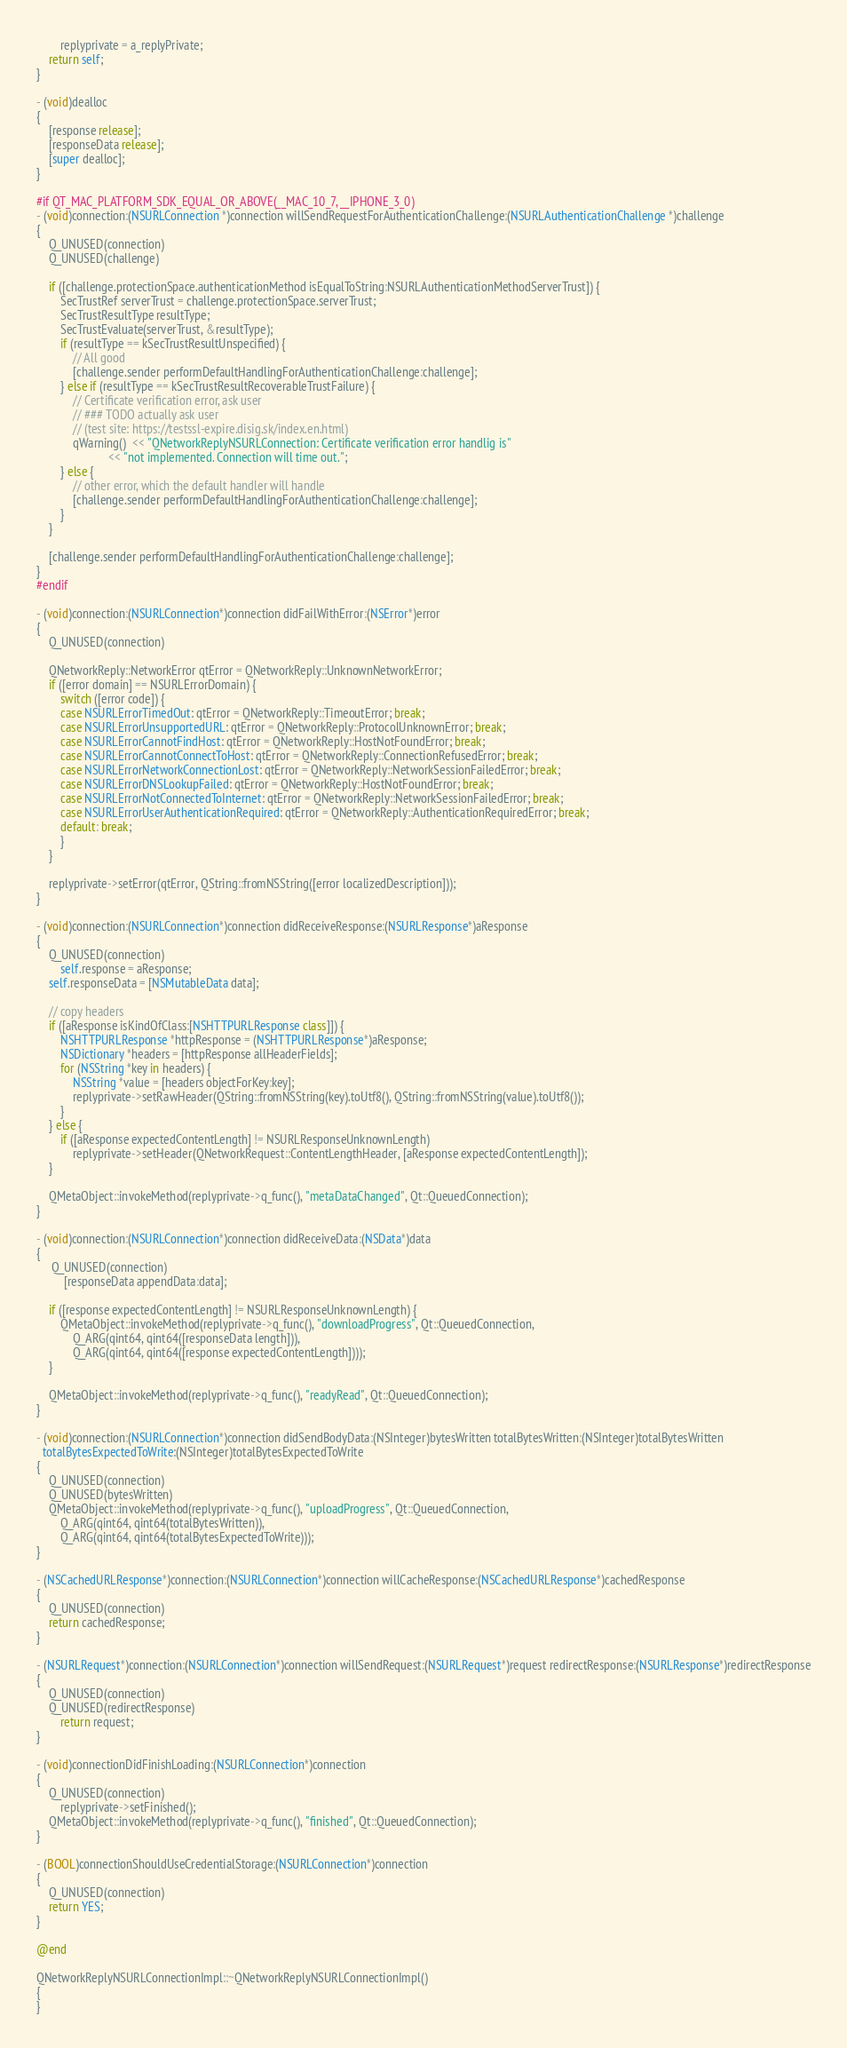<code> <loc_0><loc_0><loc_500><loc_500><_ObjectiveC_>        replyprivate = a_replyPrivate;
    return self;
}

- (void)dealloc
{
    [response release];
    [responseData release];
    [super dealloc];
}

#if QT_MAC_PLATFORM_SDK_EQUAL_OR_ABOVE(__MAC_10_7, __IPHONE_3_0)
- (void)connection:(NSURLConnection *)connection willSendRequestForAuthenticationChallenge:(NSURLAuthenticationChallenge *)challenge
{
    Q_UNUSED(connection)
    Q_UNUSED(challenge)

    if ([challenge.protectionSpace.authenticationMethod isEqualToString:NSURLAuthenticationMethodServerTrust]) {
        SecTrustRef serverTrust = challenge.protectionSpace.serverTrust;
        SecTrustResultType resultType;
        SecTrustEvaluate(serverTrust, &resultType);
        if (resultType == kSecTrustResultUnspecified) {
            // All good
            [challenge.sender performDefaultHandlingForAuthenticationChallenge:challenge];
        } else if (resultType == kSecTrustResultRecoverableTrustFailure) {
            // Certificate verification error, ask user
            // ### TODO actually ask user
            // (test site: https://testssl-expire.disig.sk/index.en.html)
            qWarning()  << "QNetworkReplyNSURLConnection: Certificate verification error handlig is"
                        << "not implemented. Connection will time out.";
        } else {
            // other error, which the default handler will handle
            [challenge.sender performDefaultHandlingForAuthenticationChallenge:challenge];
        }
    }

    [challenge.sender performDefaultHandlingForAuthenticationChallenge:challenge];
}
#endif

- (void)connection:(NSURLConnection*)connection didFailWithError:(NSError*)error
{
    Q_UNUSED(connection)

    QNetworkReply::NetworkError qtError = QNetworkReply::UnknownNetworkError;
    if ([error domain] == NSURLErrorDomain) {
        switch ([error code]) {
        case NSURLErrorTimedOut: qtError = QNetworkReply::TimeoutError; break;
        case NSURLErrorUnsupportedURL: qtError = QNetworkReply::ProtocolUnknownError; break;
        case NSURLErrorCannotFindHost: qtError = QNetworkReply::HostNotFoundError; break;
        case NSURLErrorCannotConnectToHost: qtError = QNetworkReply::ConnectionRefusedError; break;
        case NSURLErrorNetworkConnectionLost: qtError = QNetworkReply::NetworkSessionFailedError; break;
        case NSURLErrorDNSLookupFailed: qtError = QNetworkReply::HostNotFoundError; break;
        case NSURLErrorNotConnectedToInternet: qtError = QNetworkReply::NetworkSessionFailedError; break;
        case NSURLErrorUserAuthenticationRequired: qtError = QNetworkReply::AuthenticationRequiredError; break;
        default: break;
        }
    }

    replyprivate->setError(qtError, QString::fromNSString([error localizedDescription]));
}

- (void)connection:(NSURLConnection*)connection didReceiveResponse:(NSURLResponse*)aResponse
{
    Q_UNUSED(connection)
        self.response = aResponse;
    self.responseData = [NSMutableData data];

    // copy headers
    if ([aResponse isKindOfClass:[NSHTTPURLResponse class]]) {
        NSHTTPURLResponse *httpResponse = (NSHTTPURLResponse*)aResponse;
        NSDictionary *headers = [httpResponse allHeaderFields];
        for (NSString *key in headers) {
            NSString *value = [headers objectForKey:key];
            replyprivate->setRawHeader(QString::fromNSString(key).toUtf8(), QString::fromNSString(value).toUtf8());
        }
    } else {
        if ([aResponse expectedContentLength] != NSURLResponseUnknownLength)
            replyprivate->setHeader(QNetworkRequest::ContentLengthHeader, [aResponse expectedContentLength]);
    }

    QMetaObject::invokeMethod(replyprivate->q_func(), "metaDataChanged", Qt::QueuedConnection);
}

- (void)connection:(NSURLConnection*)connection didReceiveData:(NSData*)data
{
     Q_UNUSED(connection)
         [responseData appendData:data];

    if ([response expectedContentLength] != NSURLResponseUnknownLength) {
        QMetaObject::invokeMethod(replyprivate->q_func(), "downloadProgress", Qt::QueuedConnection,
            Q_ARG(qint64, qint64([responseData length])),
            Q_ARG(qint64, qint64([response expectedContentLength])));
    }

    QMetaObject::invokeMethod(replyprivate->q_func(), "readyRead", Qt::QueuedConnection);
}

- (void)connection:(NSURLConnection*)connection didSendBodyData:(NSInteger)bytesWritten totalBytesWritten:(NSInteger)totalBytesWritten
  totalBytesExpectedToWrite:(NSInteger)totalBytesExpectedToWrite
{
    Q_UNUSED(connection)
    Q_UNUSED(bytesWritten)
    QMetaObject::invokeMethod(replyprivate->q_func(), "uploadProgress", Qt::QueuedConnection,
        Q_ARG(qint64, qint64(totalBytesWritten)),
        Q_ARG(qint64, qint64(totalBytesExpectedToWrite)));
}

- (NSCachedURLResponse*)connection:(NSURLConnection*)connection willCacheResponse:(NSCachedURLResponse*)cachedResponse
{
    Q_UNUSED(connection)
    return cachedResponse;
}

- (NSURLRequest*)connection:(NSURLConnection*)connection willSendRequest:(NSURLRequest*)request redirectResponse:(NSURLResponse*)redirectResponse
{
    Q_UNUSED(connection)
    Q_UNUSED(redirectResponse)
        return request;
}

- (void)connectionDidFinishLoading:(NSURLConnection*)connection
{
    Q_UNUSED(connection)
        replyprivate->setFinished();
    QMetaObject::invokeMethod(replyprivate->q_func(), "finished", Qt::QueuedConnection);
}

- (BOOL)connectionShouldUseCredentialStorage:(NSURLConnection*)connection
{
    Q_UNUSED(connection)
    return YES;
}

@end

QNetworkReplyNSURLConnectionImpl::~QNetworkReplyNSURLConnectionImpl()
{
}
</code> 